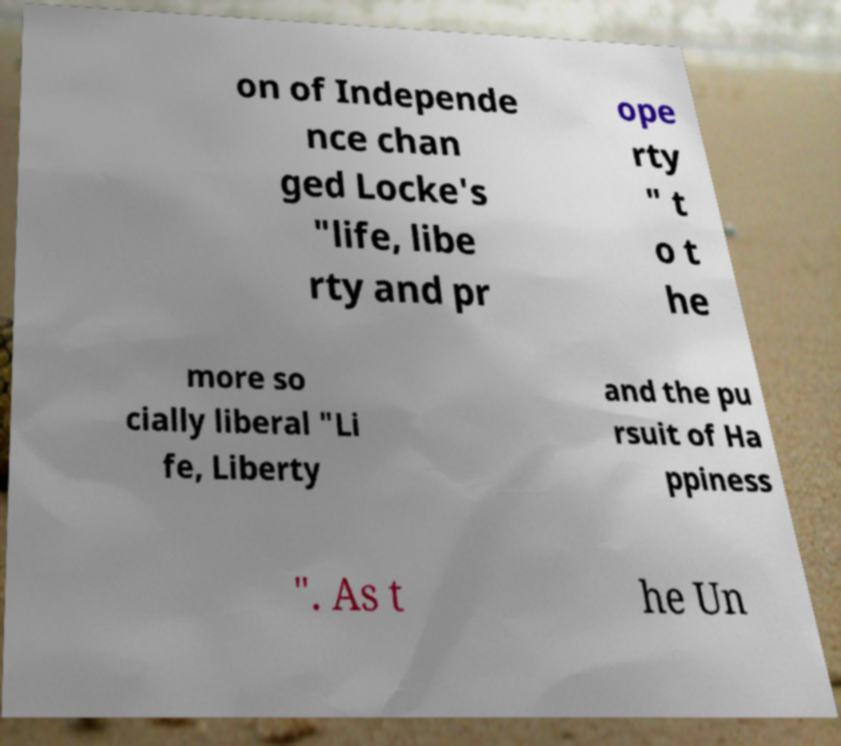Please identify and transcribe the text found in this image. on of Independe nce chan ged Locke's "life, libe rty and pr ope rty " t o t he more so cially liberal "Li fe, Liberty and the pu rsuit of Ha ppiness ". As t he Un 